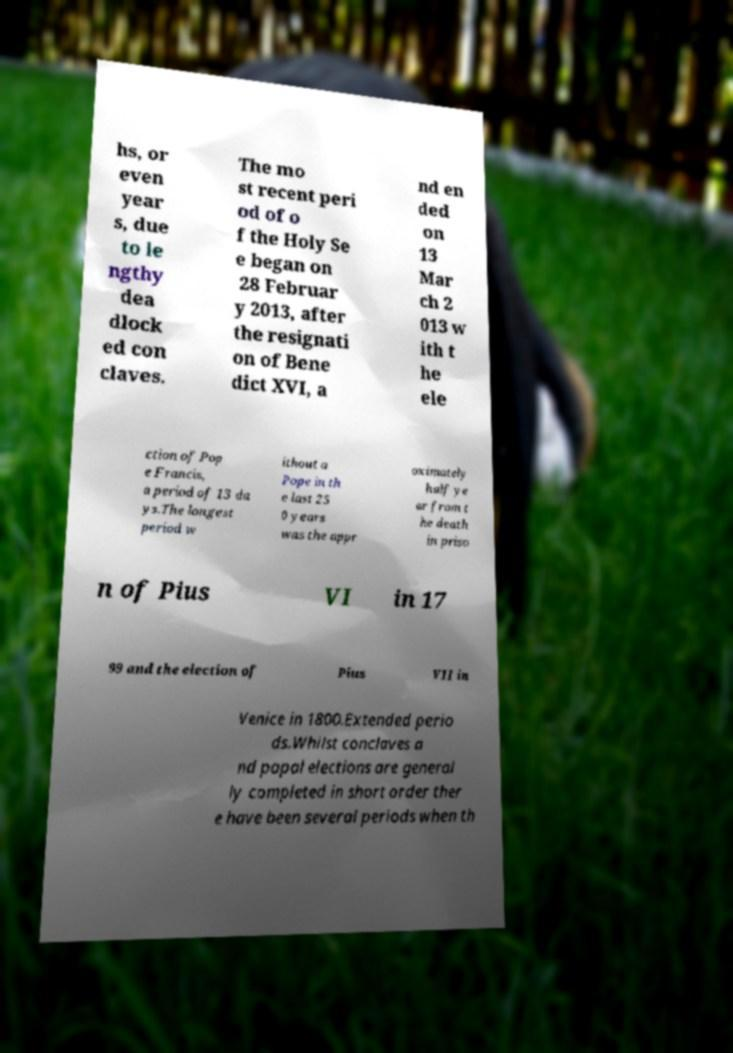I need the written content from this picture converted into text. Can you do that? hs, or even year s, due to le ngthy dea dlock ed con claves. The mo st recent peri od of o f the Holy Se e began on 28 Februar y 2013, after the resignati on of Bene dict XVI, a nd en ded on 13 Mar ch 2 013 w ith t he ele ction of Pop e Francis, a period of 13 da ys.The longest period w ithout a Pope in th e last 25 0 years was the appr oximately half ye ar from t he death in priso n of Pius VI in 17 99 and the election of Pius VII in Venice in 1800.Extended perio ds.Whilst conclaves a nd papal elections are general ly completed in short order ther e have been several periods when th 